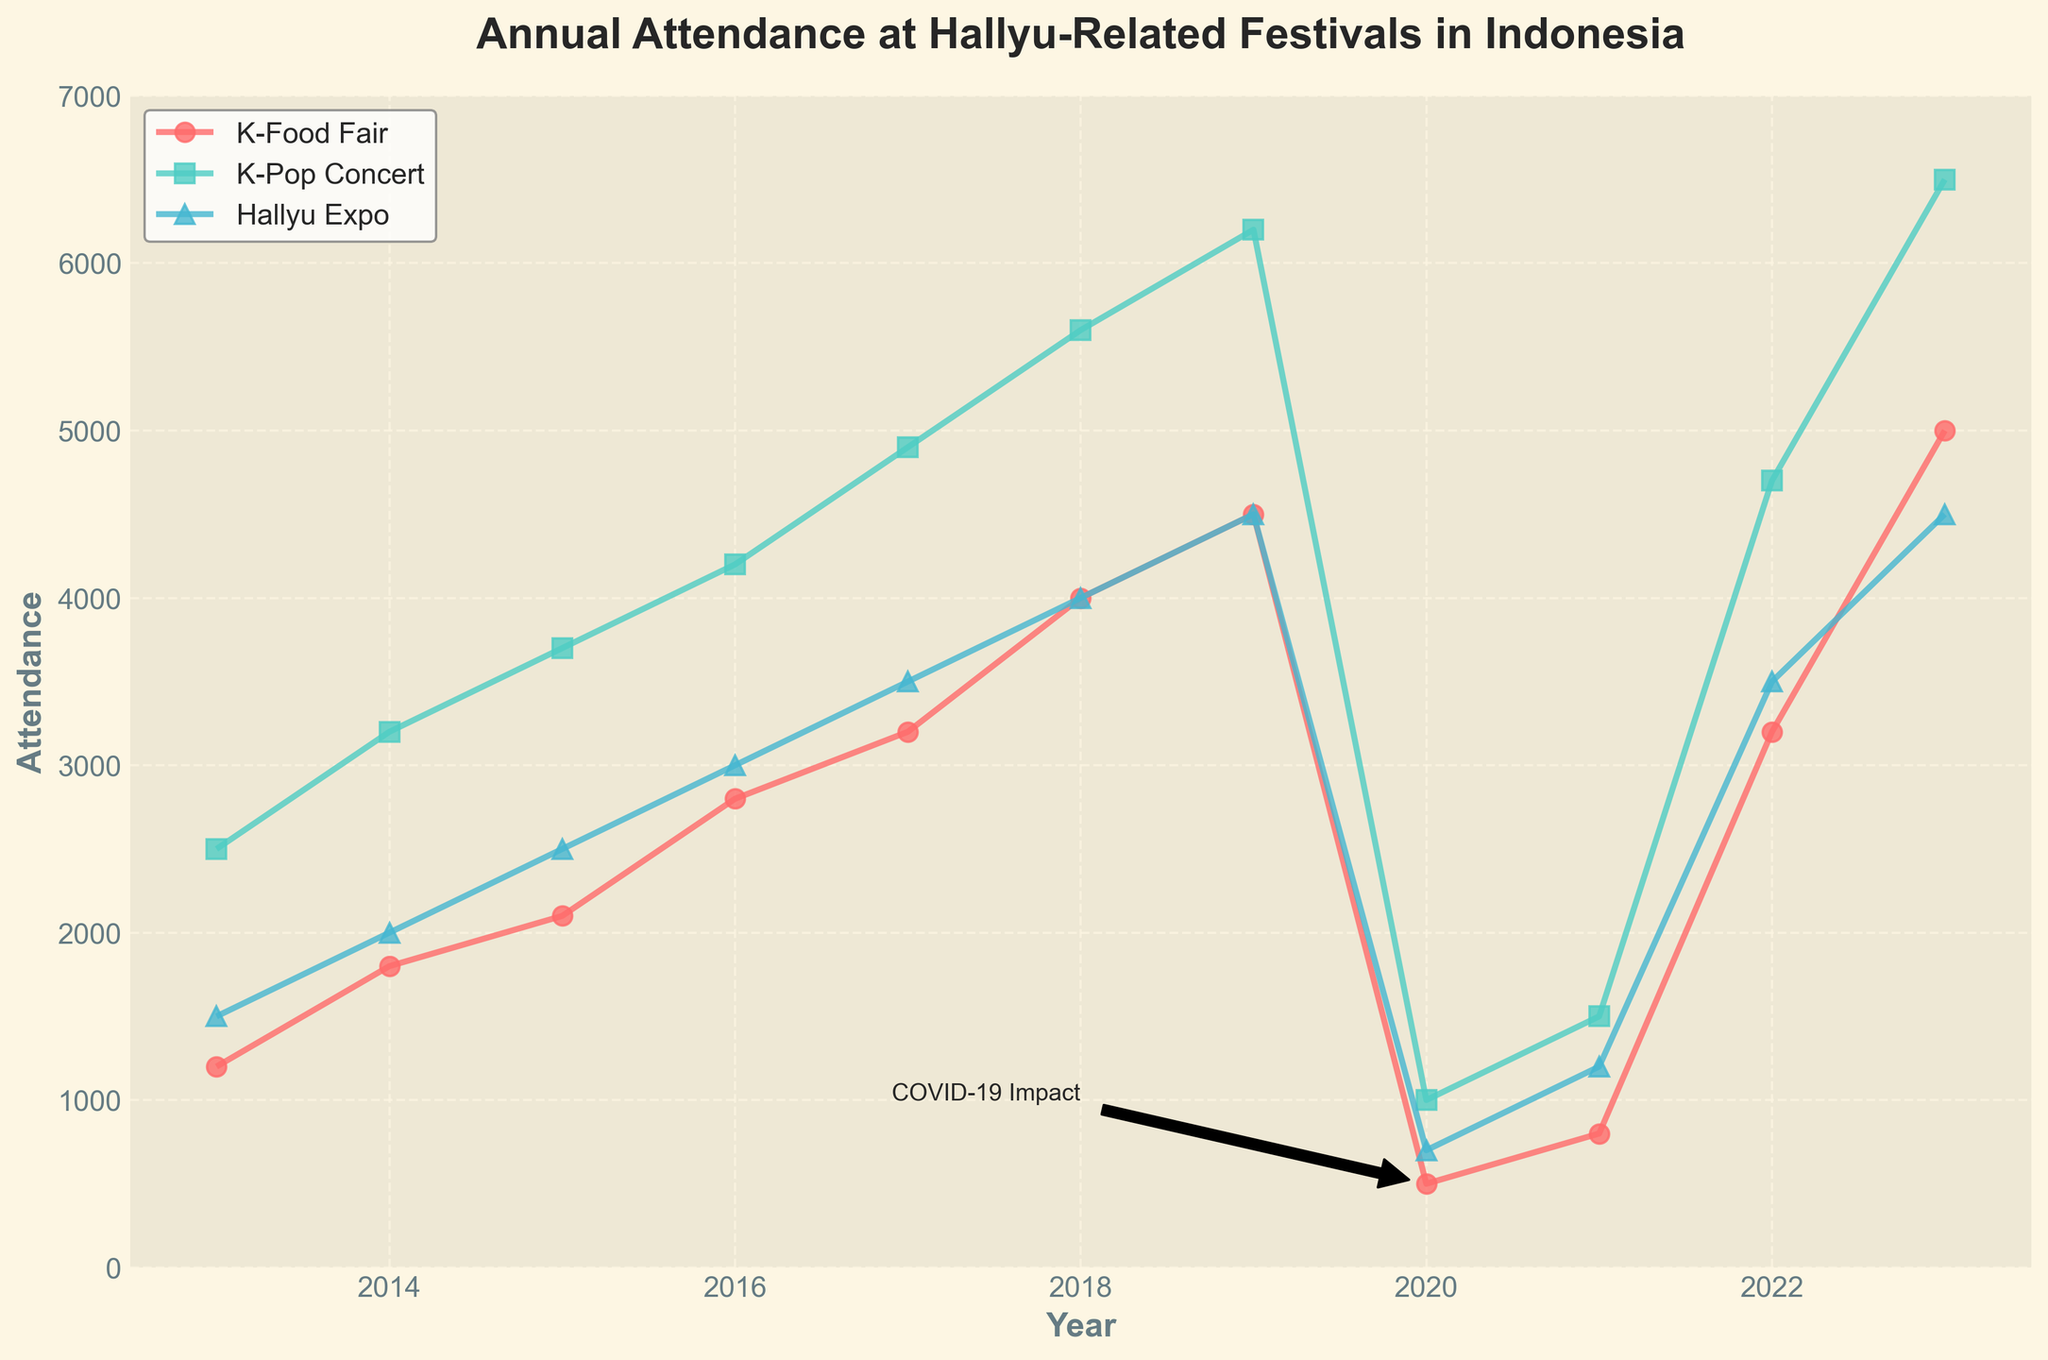What is the title of the plot? The title is displayed at the top of the plot and indicates the primary subject of the data visualization.
Answer: Annual Attendance at Hallyu-Related Festivals in Indonesia What years are covered in the plot? The x-axis shows the range of years on the plot. By analyzing the range, we can see which years are covered.
Answer: 2013 to 2023 Which event had the highest attendance in 2023? Look at the data points for the year 2023 and compare the attendance figures for different festivals.
Answer: K-Pop Concert How did the attendance at the K-Food Fair change from 2019 to 2020? Examine the data points for the K-Food Fair in both 2019 and 2020 and note the difference in attendance figures.
Answer: Decreased by 4000 What is the color used to represent the Hallyu Expo? Look at the legend on the plot which matches festival names with colors.
Answer: Blue What was the impact of COVID-19 on event attendance in 2020? Examine the attendance figures for all festivals in the year 2020 and notice a significant drop compared to previous years.
Answer: Attendance dropped significantly What is the trend in K-Pop Concert attendance from 2013 to 2023? Follow the data points representing K-Pop Concert across the years and note the general direction.
Answer: Increasing trend Which festival had the least attendance during the COVID-19 period? Check the attendance figures for all festivals in 2020 and 2021 and identify the lowest value.
Answer: K-Food Fair in 2020 How did the attendance at the Hallyu Expo recover from 2020 to 2022? Compare the attendance figures for Hallyu Expo in 2020, 2021, and 2022 to see the change in numbers.
Answer: Increased from 700 in 2020 to 3500 in 2022 Between which two consecutive years did the K-Pop Concert see its largest increase in attendance? Compare year-over-year differences in attendance for the K-Pop Concert data points to find the largest increase.
Answer: 2016 to 2017 